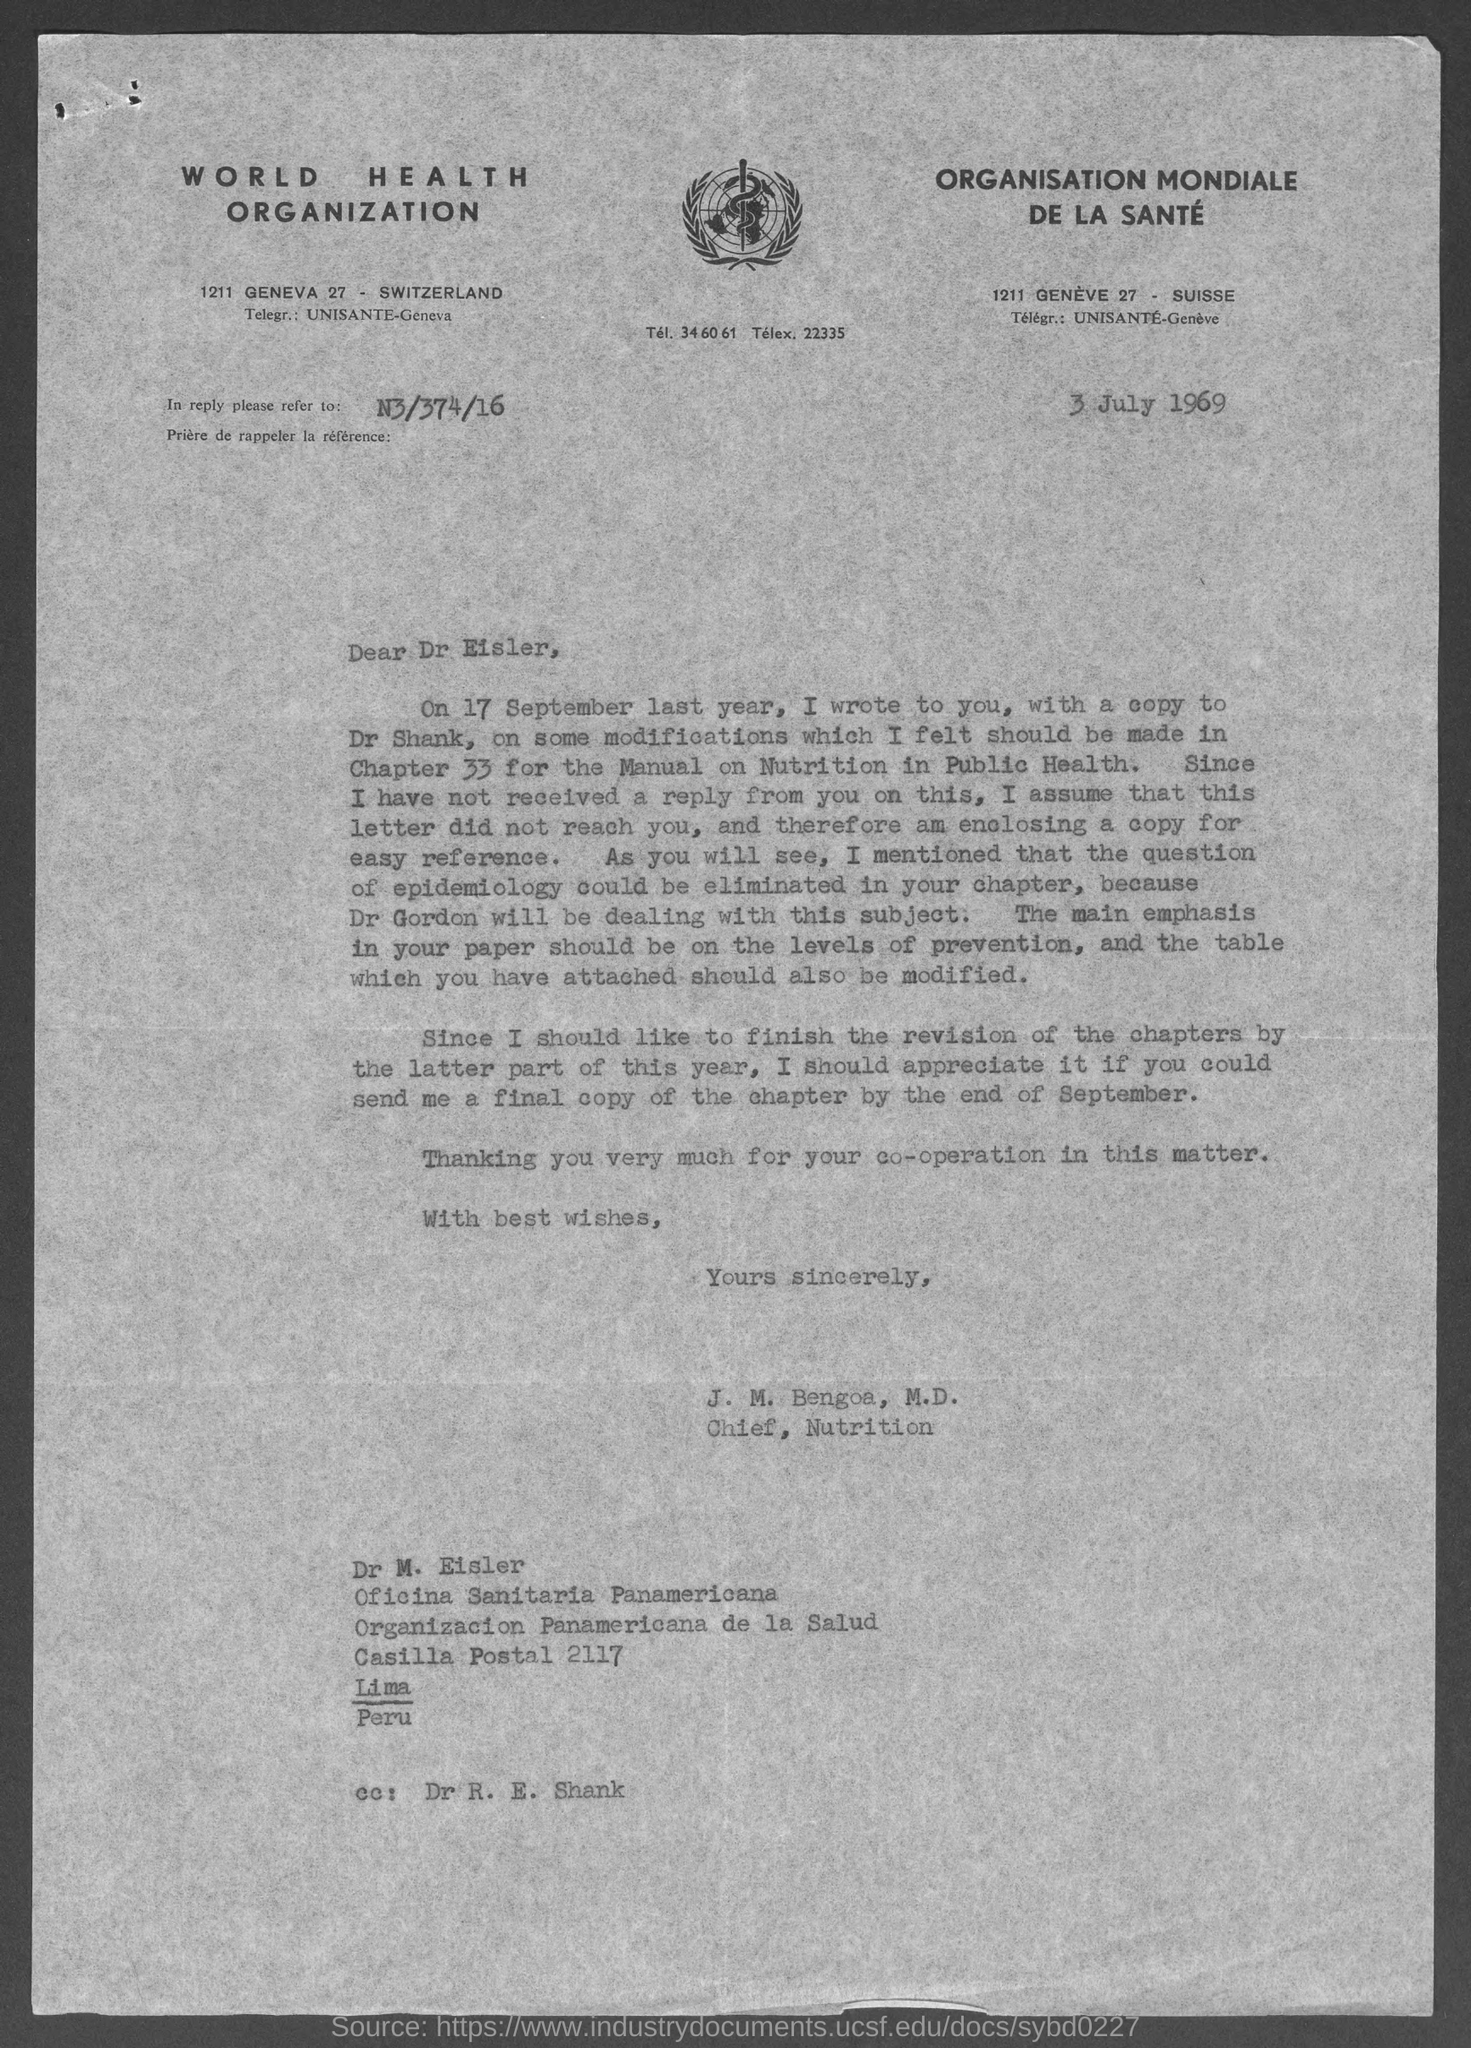List a handful of essential elements in this visual. The World Health Organization's address is located at 1211 Geneva 27, in Switzerland. To whom this letter is written is Dr. Eisler. The postal code of Casilla is 2117. 